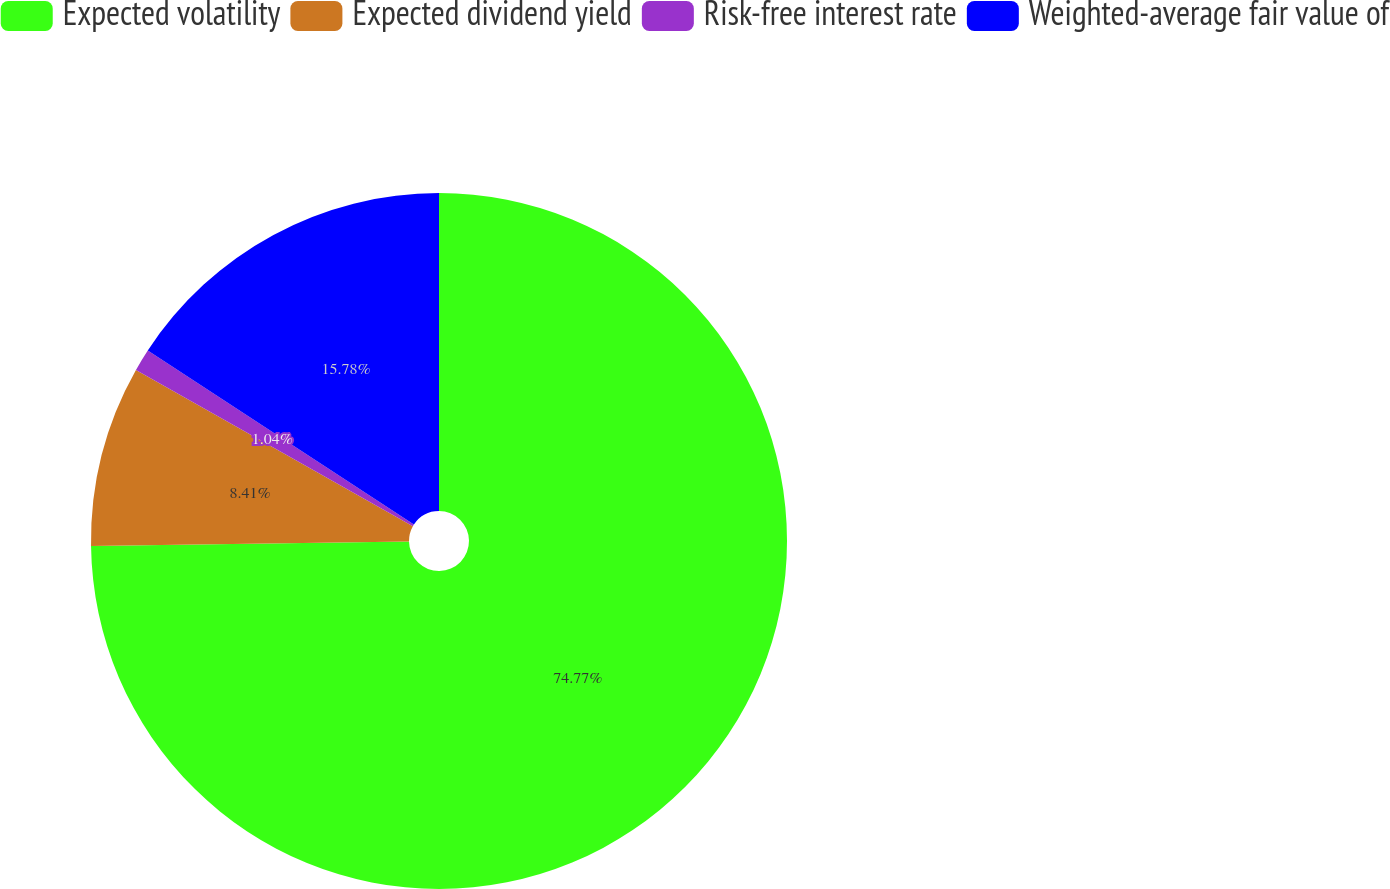<chart> <loc_0><loc_0><loc_500><loc_500><pie_chart><fcel>Expected volatility<fcel>Expected dividend yield<fcel>Risk-free interest rate<fcel>Weighted-average fair value of<nl><fcel>74.77%<fcel>8.41%<fcel>1.04%<fcel>15.78%<nl></chart> 